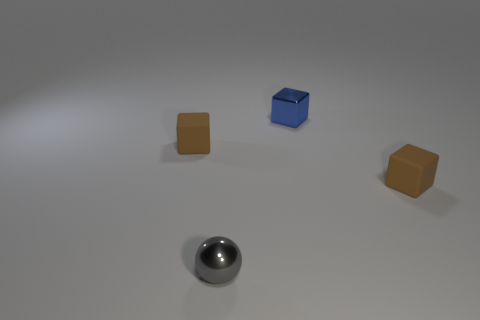Is the number of tiny objects that are to the left of the gray shiny thing greater than the number of matte blocks that are behind the tiny blue metal object?
Your answer should be very brief. Yes. Is there a large green ball?
Your response must be concise. No. What number of things are tiny gray objects or tiny gray cylinders?
Offer a terse response. 1. Are there any tiny matte blocks that have the same color as the tiny metallic cube?
Give a very brief answer. No. How many tiny rubber cubes are on the left side of the tiny brown cube that is right of the shiny block?
Give a very brief answer. 1. Is the number of small gray shiny objects greater than the number of tiny gray rubber objects?
Your answer should be very brief. Yes. Do the tiny gray object and the small blue thing have the same material?
Keep it short and to the point. Yes. Are there an equal number of small brown rubber cubes behind the blue shiny block and large brown spheres?
Give a very brief answer. Yes. What number of gray things have the same material as the tiny blue block?
Your response must be concise. 1. Is the number of blue blocks less than the number of gray blocks?
Your answer should be very brief. No. 